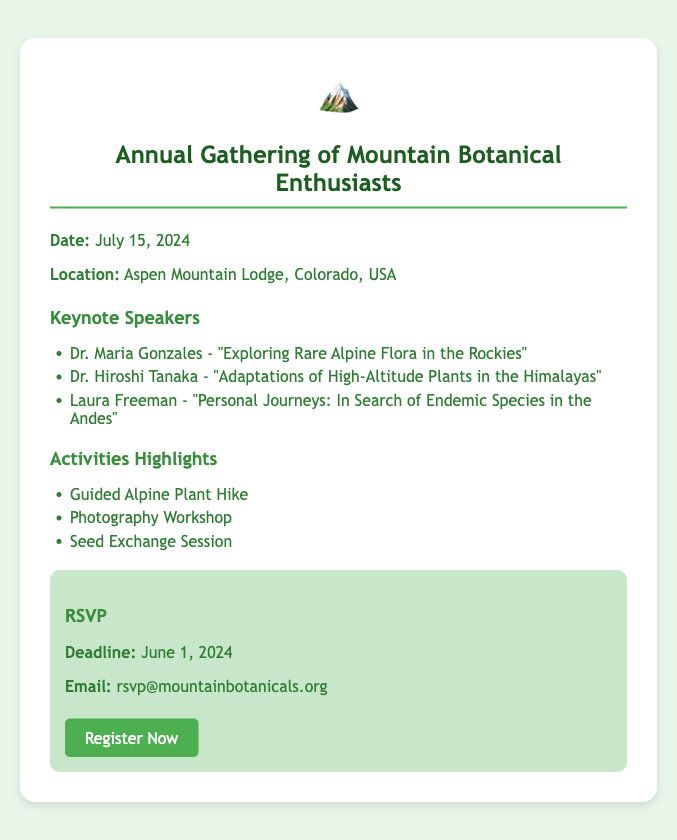What is the date of the event? The date of the event is clearly stated in the document.
Answer: July 15, 2024 Where is the gathering taking place? The location of the gathering is specified in the document.
Answer: Aspen Mountain Lodge, Colorado, USA Who is one of the keynote speakers? The document lists keynote speakers, one of them can be identified.
Answer: Dr. Maria Gonzales What is one of the activities highlighted? The document mentions various activities, of which one can be named.
Answer: Guided Alpine Plant Hike When is the RSVP deadline? The deadline for RSVP is provided in the document.
Answer: June 1, 2024 What is the email for RSVPs? The document includes an email address for RSVP communication.
Answer: rsvp@mountainbotanicals.org How many keynote speakers are listed? The number of speakers is a detail presented in the document.
Answer: Three Which speaker focuses on the Himalayas? The document attributes a specific topic to one speaker concerning the Himalayas.
Answer: Dr. Hiroshi Tanaka What type of workshop is mentioned? The document specifies a type of workshop being offered at the event.
Answer: Photography Workshop 